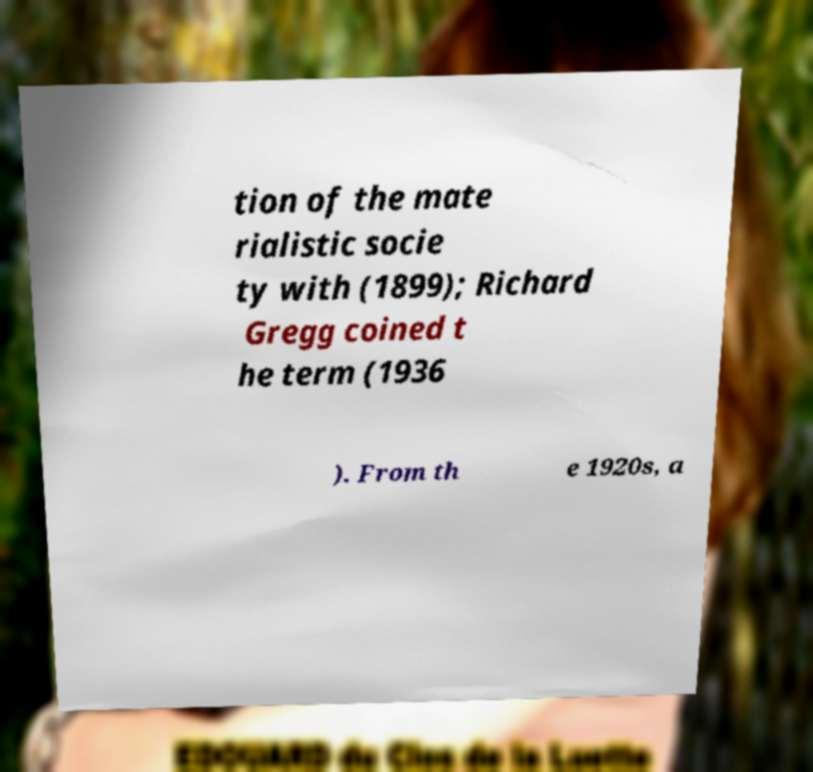There's text embedded in this image that I need extracted. Can you transcribe it verbatim? tion of the mate rialistic socie ty with (1899); Richard Gregg coined t he term (1936 ). From th e 1920s, a 